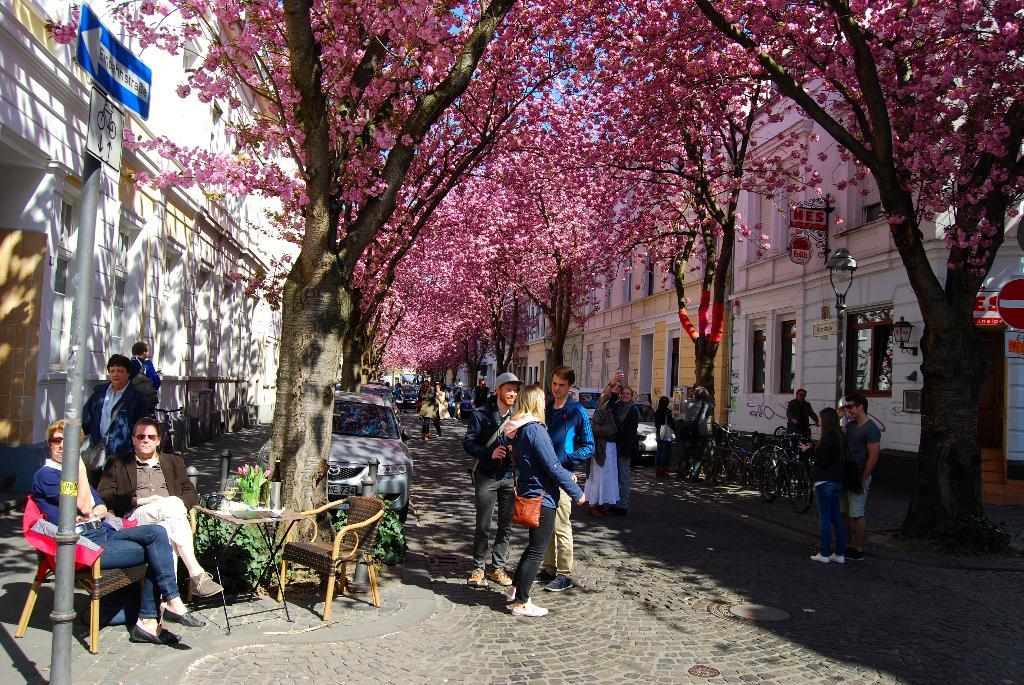What is happening in the image? There are people on the street. Can you describe the positions of some of the people? Some people are sitting beside the road, while others are standing. What type of animals can be seen in the school in the image? There is no school or animals present in the image; it features people on the street. What kind of bag is being used by the people in the zoo in the image? There is no zoo or bags present in the image; it features people on the street. 